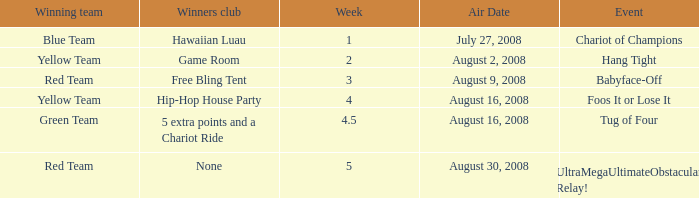Which Winners club has an Event of hang tight? Game Room. 